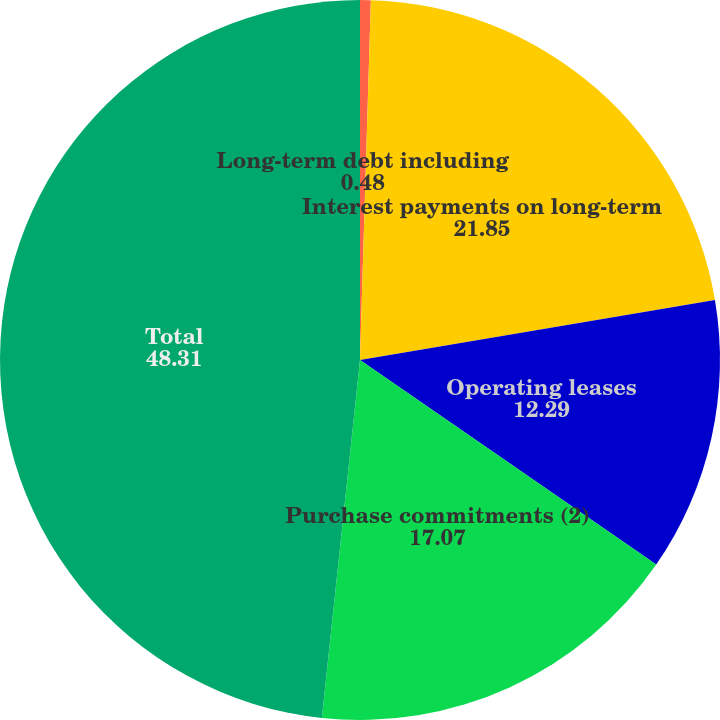Convert chart. <chart><loc_0><loc_0><loc_500><loc_500><pie_chart><fcel>Long-term debt including<fcel>Interest payments on long-term<fcel>Operating leases<fcel>Purchase commitments (2)<fcel>Total<nl><fcel>0.48%<fcel>21.85%<fcel>12.29%<fcel>17.07%<fcel>48.31%<nl></chart> 